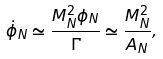Convert formula to latex. <formula><loc_0><loc_0><loc_500><loc_500>\dot { \phi } _ { N } \simeq \frac { M _ { N } ^ { 2 } \phi _ { N } } { \Gamma } \simeq \frac { M _ { N } ^ { 2 } } { A _ { N } } ,</formula> 